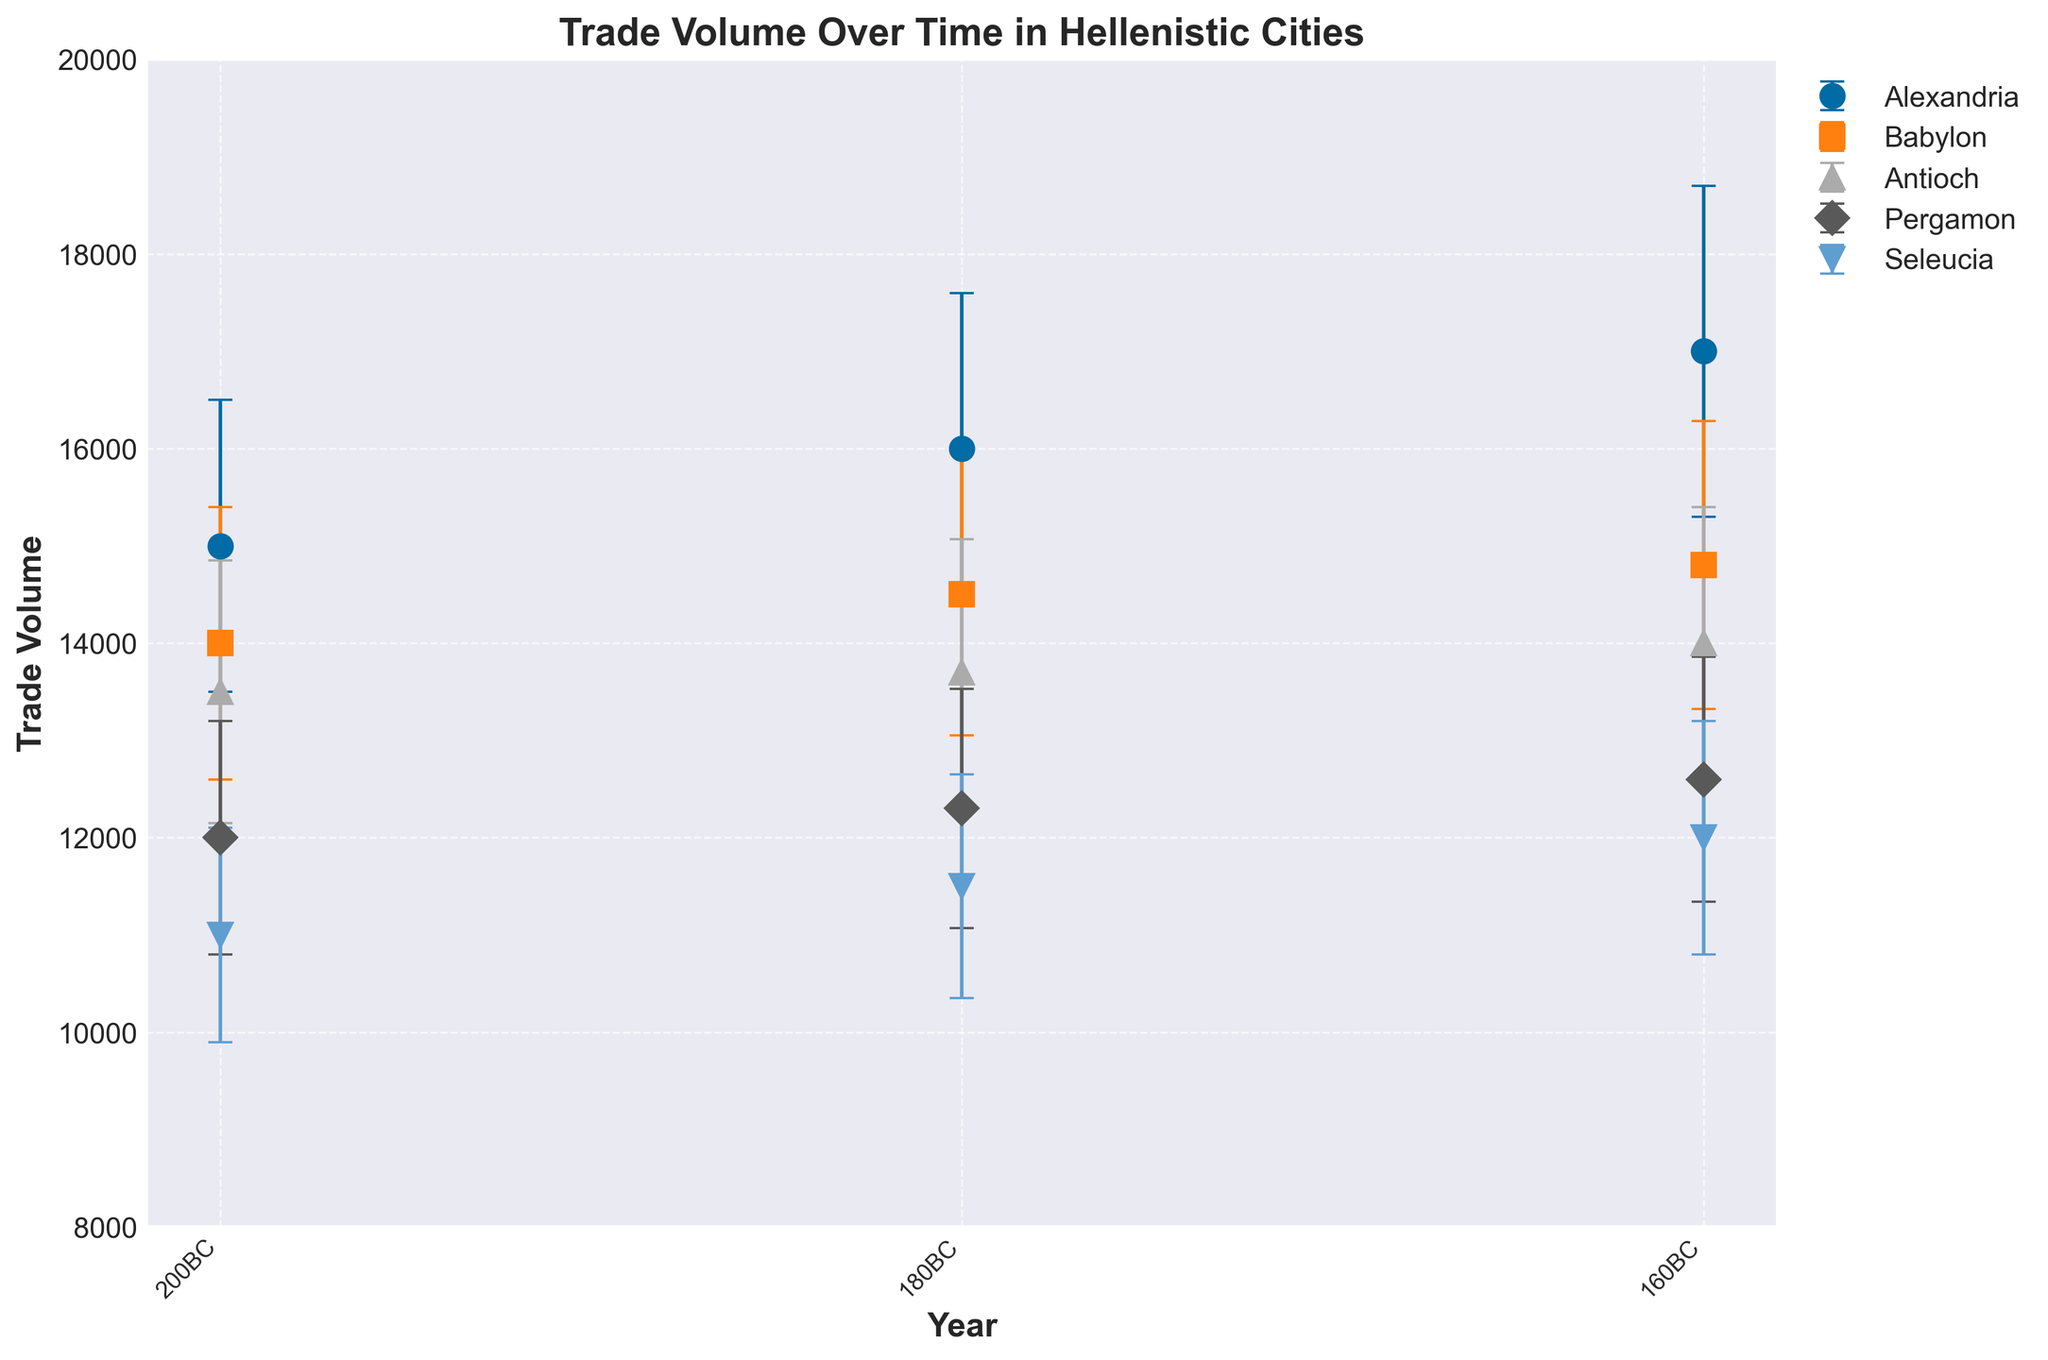What is the title of the plot? The title is the first text element usually found at the top of the graph. It summarizes the main idea or purpose of the plot. In this case, it reads 'Trade Volume Over Time in Hellenistic Cities'.
Answer: Trade Volume Over Time in Hellenistic Cities How many cities are represented in the plot? The plot legend, which helps identify the different data series, shows each city's name. In this case, the legend lists Alexandria, Babylon, Antioch, Pergamon, and Seleucia, making it five cities in total.
Answer: Five Which city had the highest trade volume in 160BC? To determine the highest trade volume in a specific year, look at the data points in the year 160BC and compare their heights. Alexandria had the highest trade volume at 17,000.
Answer: Alexandria What is the overall trend in trade volume for Seleucia from 200BC to 160BC? By observing the data points for Seleucia over the three years - 200BC, 180BC, and 160BC - it's clear that the trade volume consistently increased from 11,000 to 12,000.
Answer: Increasing Which city showed the least variability in trade volume over time? Variability can be inferred from the error bars' lengths. The shorter the error bars, the less the variability. Pergamon seems to have the shortest error bars among the cities.
Answer: Pergamon Between which years did Babylon have the smallest increase in trade volume? To find the smallest increase, compare the difference in trade volumes between consecutive years for Babylon. Between 200BC and 180BC, the increase is 500, and between 180BC and 160BC, the increase is 300. Therefore, the smallest increase occurred between 180BC and 160BC.
Answer: Between 180BC and 160BC In 180BC, which city had the second-highest trade volume? In 180BC, identify and compare the data points of all cities. Babylon had the highest, followed by Alexandria with a trade volume of 16,000.
Answer: Alexandria What can you infer about the trend of Antioch’s trade volume between each interval? By comparing Antioch’s trade volumes for the years provided, it increased from 13,500 to 14,000 across the intervals 200BC to 180BC, and then 180BC to 160BC. The trend shows a steady increase.
Answer: Steady increase By how much did Pergamon's trade volume increase from 200BC to 160BC? Calculate the difference in trade volumes for Pergamon between these years. Subtracting 12,000 from 12,600 equals an increase of 600.
Answer: 600 Which city showed an overall downward trend in trade volume? Observing all cities' data points over time, none of them display a downward trend; they all show signs of increasing trade volume except for some minor fluctuations.
Answer: None 